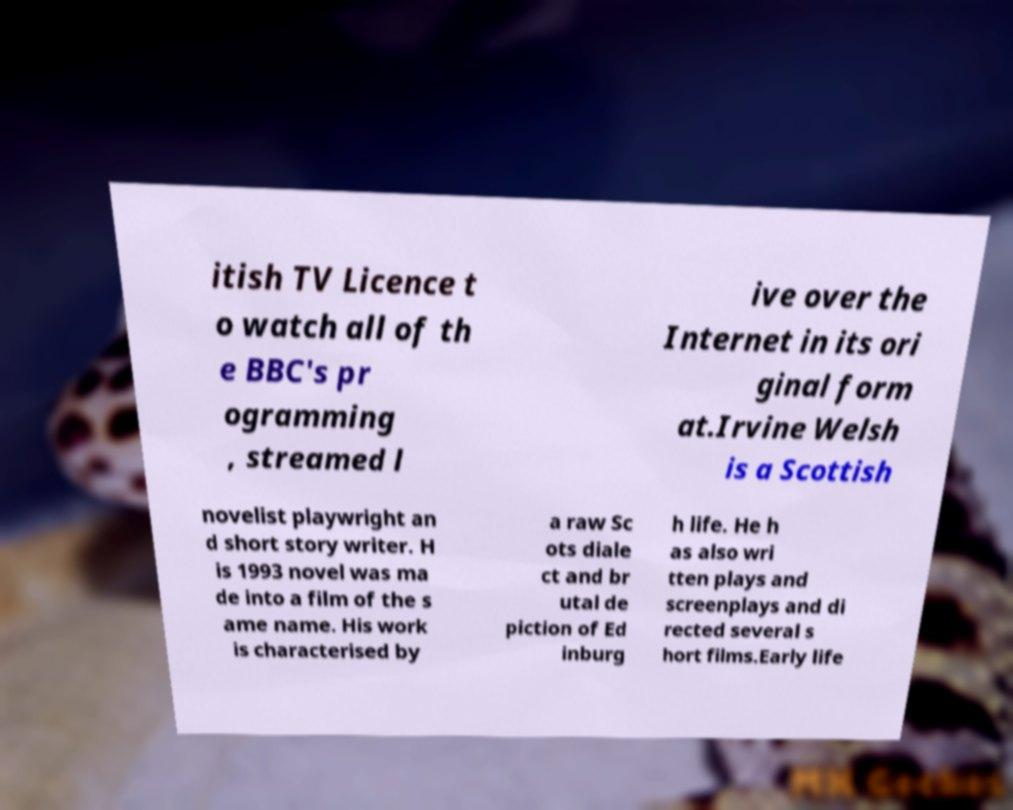There's text embedded in this image that I need extracted. Can you transcribe it verbatim? itish TV Licence t o watch all of th e BBC's pr ogramming , streamed l ive over the Internet in its ori ginal form at.Irvine Welsh is a Scottish novelist playwright an d short story writer. H is 1993 novel was ma de into a film of the s ame name. His work is characterised by a raw Sc ots diale ct and br utal de piction of Ed inburg h life. He h as also wri tten plays and screenplays and di rected several s hort films.Early life 